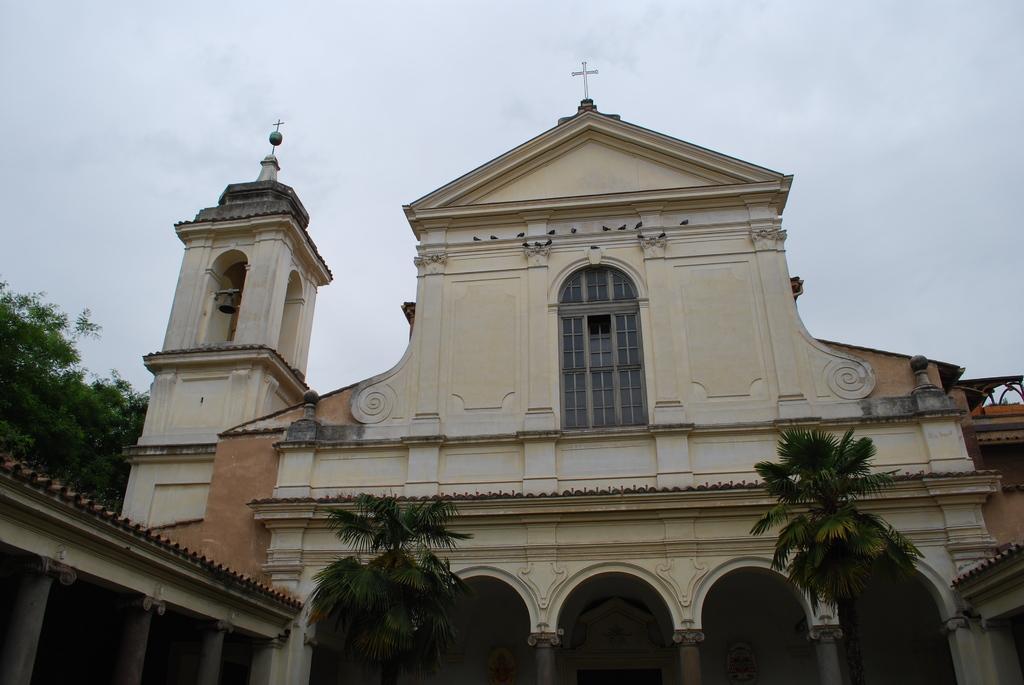Could you give a brief overview of what you see in this image? There are trees, a church and a roof in the foreground area of the image, there are trees and the sky in the background. 